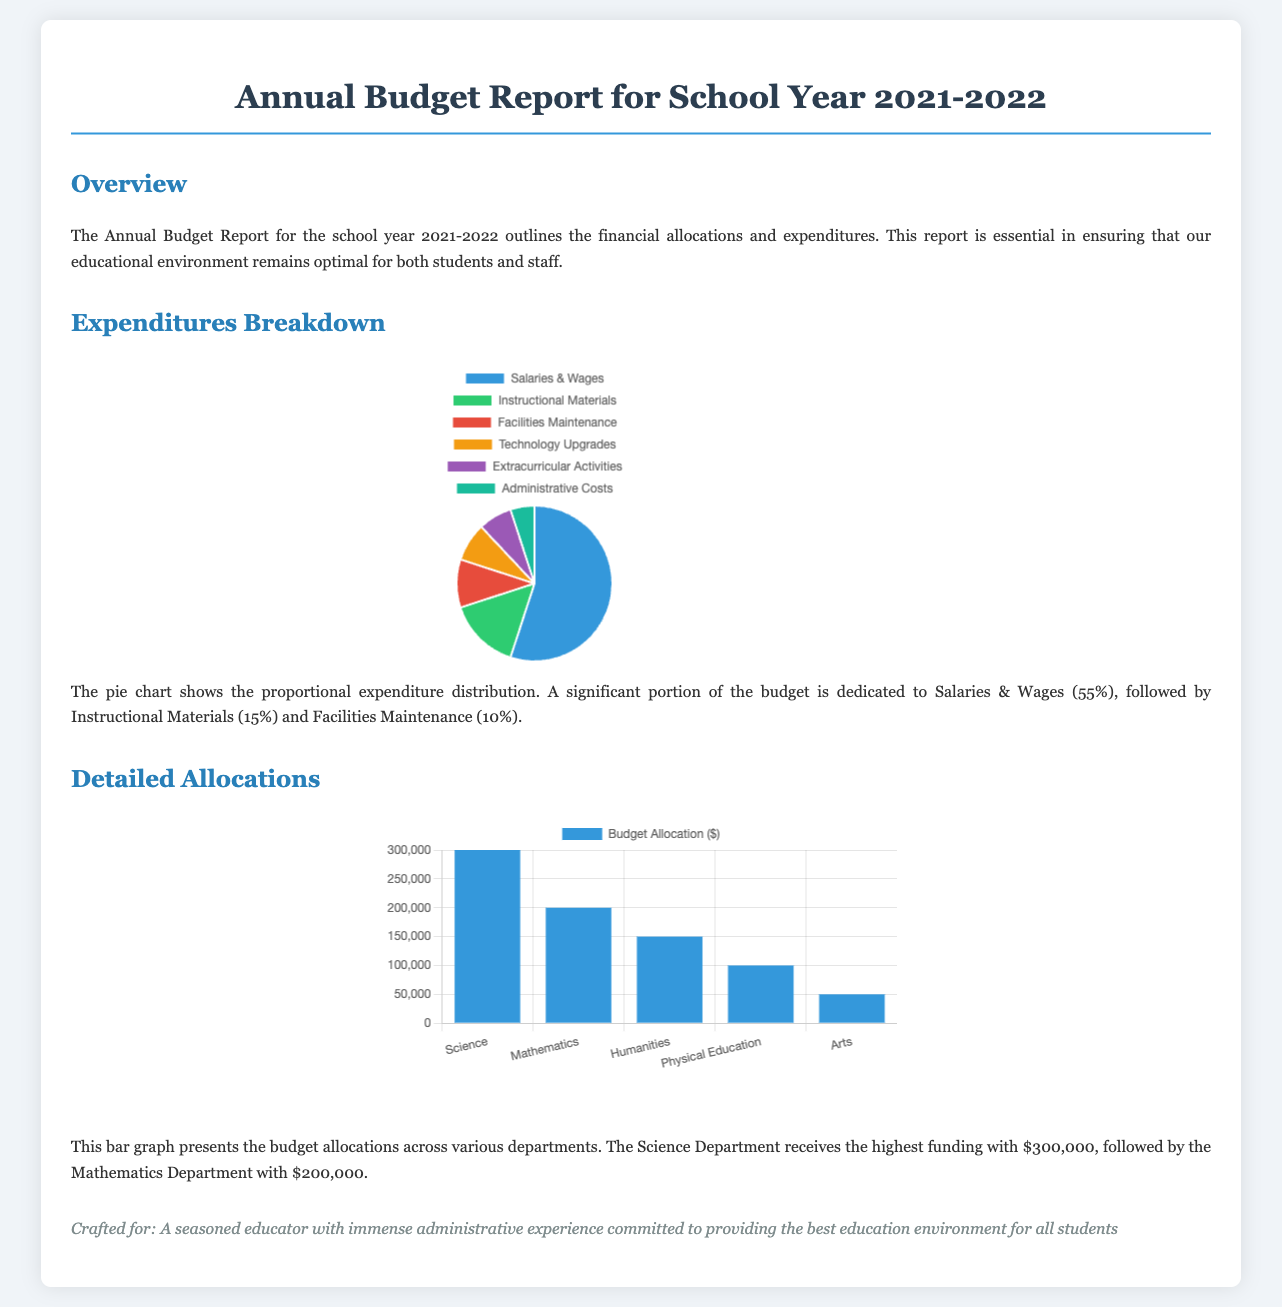What percentage of the budget is allocated to Salaries & Wages? According to the pie chart, Salaries & Wages account for 55% of the total expenditures.
Answer: 55% Which department receives the highest funding allocation? The text states that the Science Department receives the highest funding with $300,000.
Answer: Science Department What is the total budget allocation for the Humanities Department? The report lists the Humanities Department's budget allocation as $150,000 in the bar graph.
Answer: $150,000 How much is allocated to Extracurricular Activities? The pie chart indicates that Extracurricular Activities account for 7% of the total expenditures.
Answer: 7% What type of graph is used to represent expenditures? The document indicates that a pie chart is used to visualize the expenditures breakdown.
Answer: Pie Chart What is the lowest budget allocation among the listed departments? The bar graph shows that the Arts Department has the lowest budget allocation of $50,000.
Answer: $50,000 How are the expenditures categorized? The pie chart categorizes expenditures into multiple areas including Salaries & Wages, Instructional Materials, and others.
Answer: Multiple areas What year does this budget report cover? The title of the document explicitly states that it covers the school year 2021-2022.
Answer: 2021-2022 What color represents the Technology Upgrades in the pie chart? The code indicates that Technology Upgrades are represented by the color corresponding to 8% in the chart.
Answer: Orange 